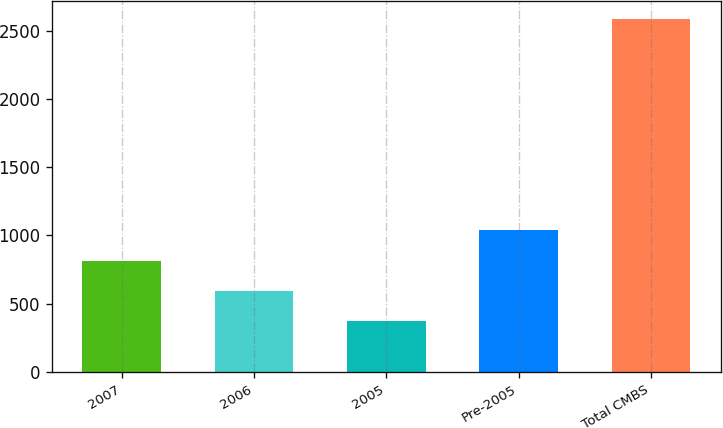<chart> <loc_0><loc_0><loc_500><loc_500><bar_chart><fcel>2007<fcel>2006<fcel>2005<fcel>Pre-2005<fcel>Total CMBS<nl><fcel>815.6<fcel>594.3<fcel>373<fcel>1036.9<fcel>2586<nl></chart> 